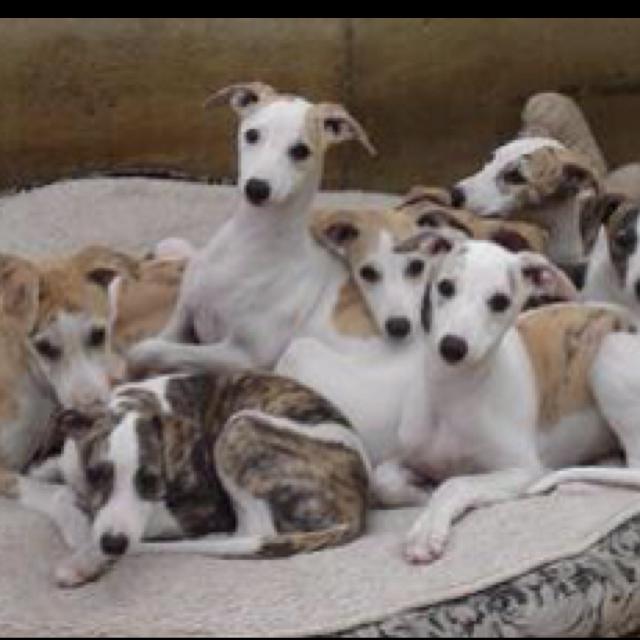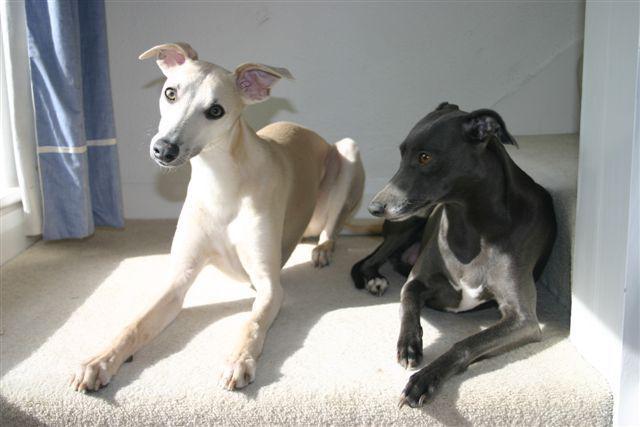The first image is the image on the left, the second image is the image on the right. Assess this claim about the two images: "Three hounds with heads turned in the same direction, pose standing next to one another, in ascending size order.". Correct or not? Answer yes or no. No. The first image is the image on the left, the second image is the image on the right. Analyze the images presented: Is the assertion "There is exactly three dogs in the right image." valid? Answer yes or no. No. 